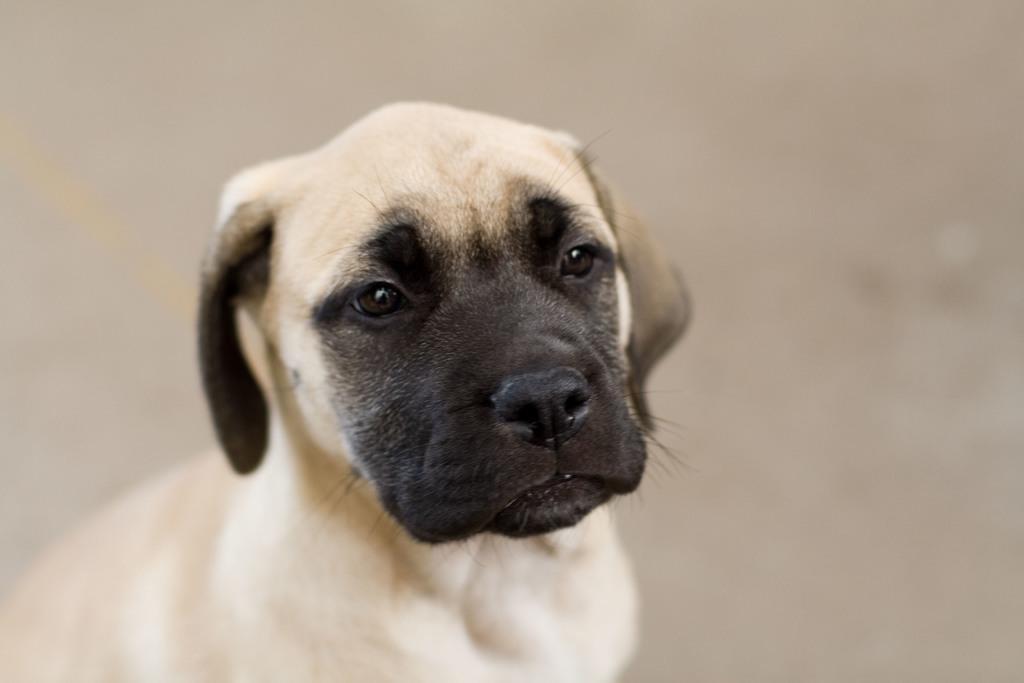Could you give a brief overview of what you see in this image? In this picture we can see a dog in the front, there is a blurry background. 